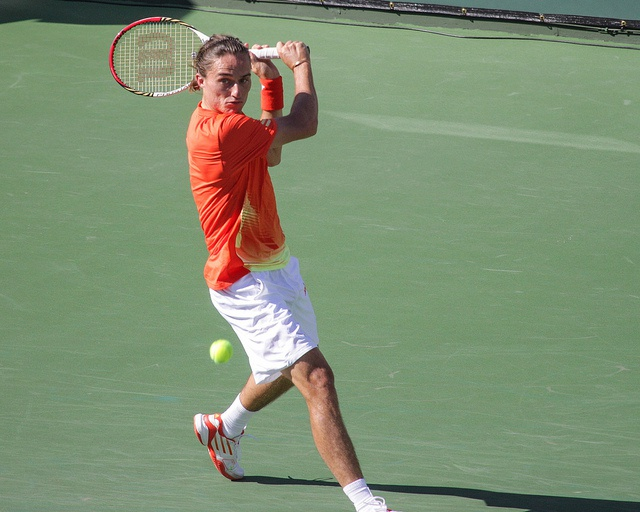Describe the objects in this image and their specific colors. I can see people in black, maroon, white, and darkgray tones, tennis racket in black, darkgray, gray, and lightgray tones, and sports ball in black, khaki, lightyellow, and lightgreen tones in this image. 